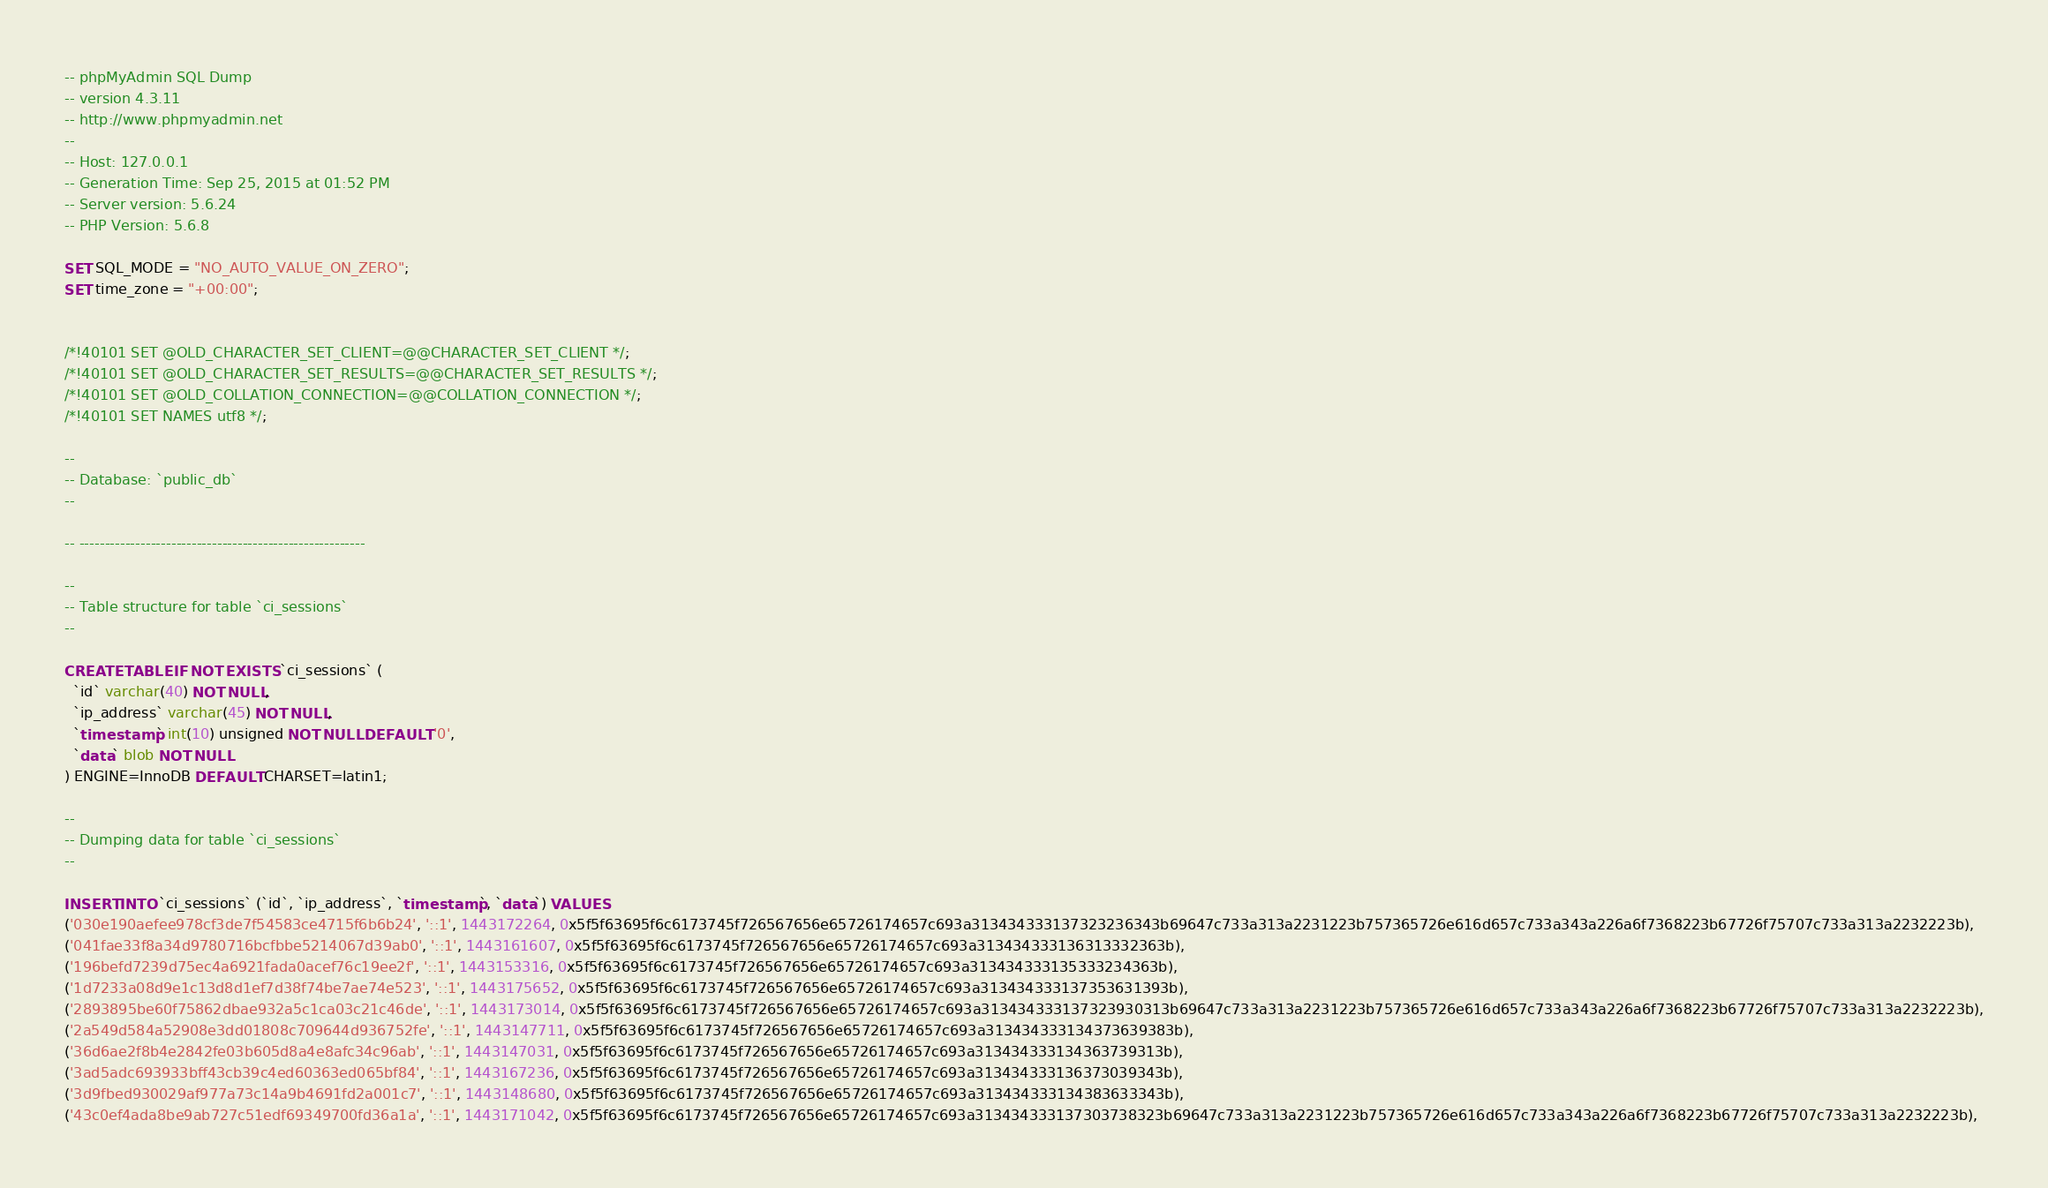Convert code to text. <code><loc_0><loc_0><loc_500><loc_500><_SQL_>-- phpMyAdmin SQL Dump
-- version 4.3.11
-- http://www.phpmyadmin.net
--
-- Host: 127.0.0.1
-- Generation Time: Sep 25, 2015 at 01:52 PM
-- Server version: 5.6.24
-- PHP Version: 5.6.8

SET SQL_MODE = "NO_AUTO_VALUE_ON_ZERO";
SET time_zone = "+00:00";


/*!40101 SET @OLD_CHARACTER_SET_CLIENT=@@CHARACTER_SET_CLIENT */;
/*!40101 SET @OLD_CHARACTER_SET_RESULTS=@@CHARACTER_SET_RESULTS */;
/*!40101 SET @OLD_COLLATION_CONNECTION=@@COLLATION_CONNECTION */;
/*!40101 SET NAMES utf8 */;

--
-- Database: `public_db`
--

-- --------------------------------------------------------

--
-- Table structure for table `ci_sessions`
--

CREATE TABLE IF NOT EXISTS `ci_sessions` (
  `id` varchar(40) NOT NULL,
  `ip_address` varchar(45) NOT NULL,
  `timestamp` int(10) unsigned NOT NULL DEFAULT '0',
  `data` blob NOT NULL
) ENGINE=InnoDB DEFAULT CHARSET=latin1;

--
-- Dumping data for table `ci_sessions`
--

INSERT INTO `ci_sessions` (`id`, `ip_address`, `timestamp`, `data`) VALUES
('030e190aefee978cf3de7f54583ce4715f6b6b24', '::1', 1443172264, 0x5f5f63695f6c6173745f726567656e65726174657c693a313434333137323236343b69647c733a313a2231223b757365726e616d657c733a343a226a6f7368223b67726f75707c733a313a2232223b),
('041fae33f8a34d9780716bcfbbe5214067d39ab0', '::1', 1443161607, 0x5f5f63695f6c6173745f726567656e65726174657c693a313434333136313332363b),
('196befd7239d75ec4a6921fada0acef76c19ee2f', '::1', 1443153316, 0x5f5f63695f6c6173745f726567656e65726174657c693a313434333135333234363b),
('1d7233a08d9e1c13d8d1ef7d38f74be7ae74e523', '::1', 1443175652, 0x5f5f63695f6c6173745f726567656e65726174657c693a313434333137353631393b),
('2893895be60f75862dbae932a5c1ca03c21c46de', '::1', 1443173014, 0x5f5f63695f6c6173745f726567656e65726174657c693a313434333137323930313b69647c733a313a2231223b757365726e616d657c733a343a226a6f7368223b67726f75707c733a313a2232223b),
('2a549d584a52908e3dd01808c709644d936752fe', '::1', 1443147711, 0x5f5f63695f6c6173745f726567656e65726174657c693a313434333134373639383b),
('36d6ae2f8b4e2842fe03b605d8a4e8afc34c96ab', '::1', 1443147031, 0x5f5f63695f6c6173745f726567656e65726174657c693a313434333134363739313b),
('3ad5adc693933bff43cb39c4ed60363ed065bf84', '::1', 1443167236, 0x5f5f63695f6c6173745f726567656e65726174657c693a313434333136373039343b),
('3d9fbed930029af977a73c14a9b4691fd2a001c7', '::1', 1443148680, 0x5f5f63695f6c6173745f726567656e65726174657c693a313434333134383633343b),
('43c0ef4ada8be9ab727c51edf69349700fd36a1a', '::1', 1443171042, 0x5f5f63695f6c6173745f726567656e65726174657c693a313434333137303738323b69647c733a313a2231223b757365726e616d657c733a343a226a6f7368223b67726f75707c733a313a2232223b),</code> 